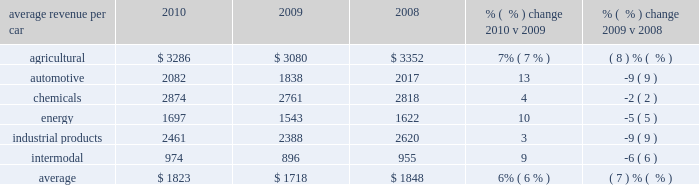Average revenue per car 2010 2009 2008 % (  % ) change 2010 v 2009 % (  % ) change 2009 v 2008 .
Agricultural products 2013 higher volume , fuel surcharges , and price improvements increased agricultural freight revenue in 2010 versus 2009 .
Increased shipments from the midwest to export ports in the pacific northwest combined with heightened demand in mexico drove higher corn and feed grain shipments in 2010 .
Increased corn and feed grain shipments into ethanol plants in california and idaho and continued growth in ethanol shipments also contributed to this increase .
In 2009 , some ethanol plants temporarily ceased operations due to lower ethanol margins , which contributed to the favorable year-over-year comparison .
In addition , strong export demand for u.s .
Wheat via the gulf ports increased shipments of wheat and food grains compared to 2009 .
Declines in domestic wheat and food shipments partially offset the growth in export shipments .
New business in feed and animal protein shipments also increased agricultural shipments in 2010 compared to 2009 .
Lower volume and fuel surcharges decreased agricultural freight revenue in 2009 versus 2008 .
Price improvements partially offset these declines .
Lower demand in both export and domestic markets led to fewer shipments of corn and feed grains , down 11% ( 11 % ) in 2009 compared to 2008 .
Weaker worldwide demand also reduced export shipments of wheat and food grains in 2009 versus 2008 .
Automotive 2013 37% ( 37 % ) and 24% ( 24 % ) increases in shipments of finished vehicles and automotive parts in 2010 , respectively , combined with core pricing gains and fuel surcharges , improved automotive freight revenue from relatively weak 2009 levels .
Economic conditions in 2009 led to poor auto sales and reduced vehicle production , which in turn reduced shipments of finished vehicles and parts during the declines in shipments of finished vehicles and auto parts and lower fuel surcharges reduced freight revenue in 2009 compared to 2008 .
Vehicle shipments were down 35% ( 35 % ) and parts were down 24% ( 24 % ) .
Core pricing gains partially offset these declines .
These volume declines resulted from economic conditions that reduced sales and vehicle production .
In addition , two major domestic automotive manufacturers declared bankruptcy in the second quarter of 2009 , affecting production levels .
Although the federal car allowance rebate system ( the 201ccash for clunkers 201d program ) helped stimulate vehicle sales and shipments in the third quarter of 2009 , production cuts and soft demand throughout the year more than offset the program 2019s benefits .
2010 agricultural revenue 2010 automotive revenue .
What was the average revenue in agriculture , in millions , from 2008-2010? 
Computations: (((3286 + 3080) + 3352) / 3)
Answer: 3239.33333. 